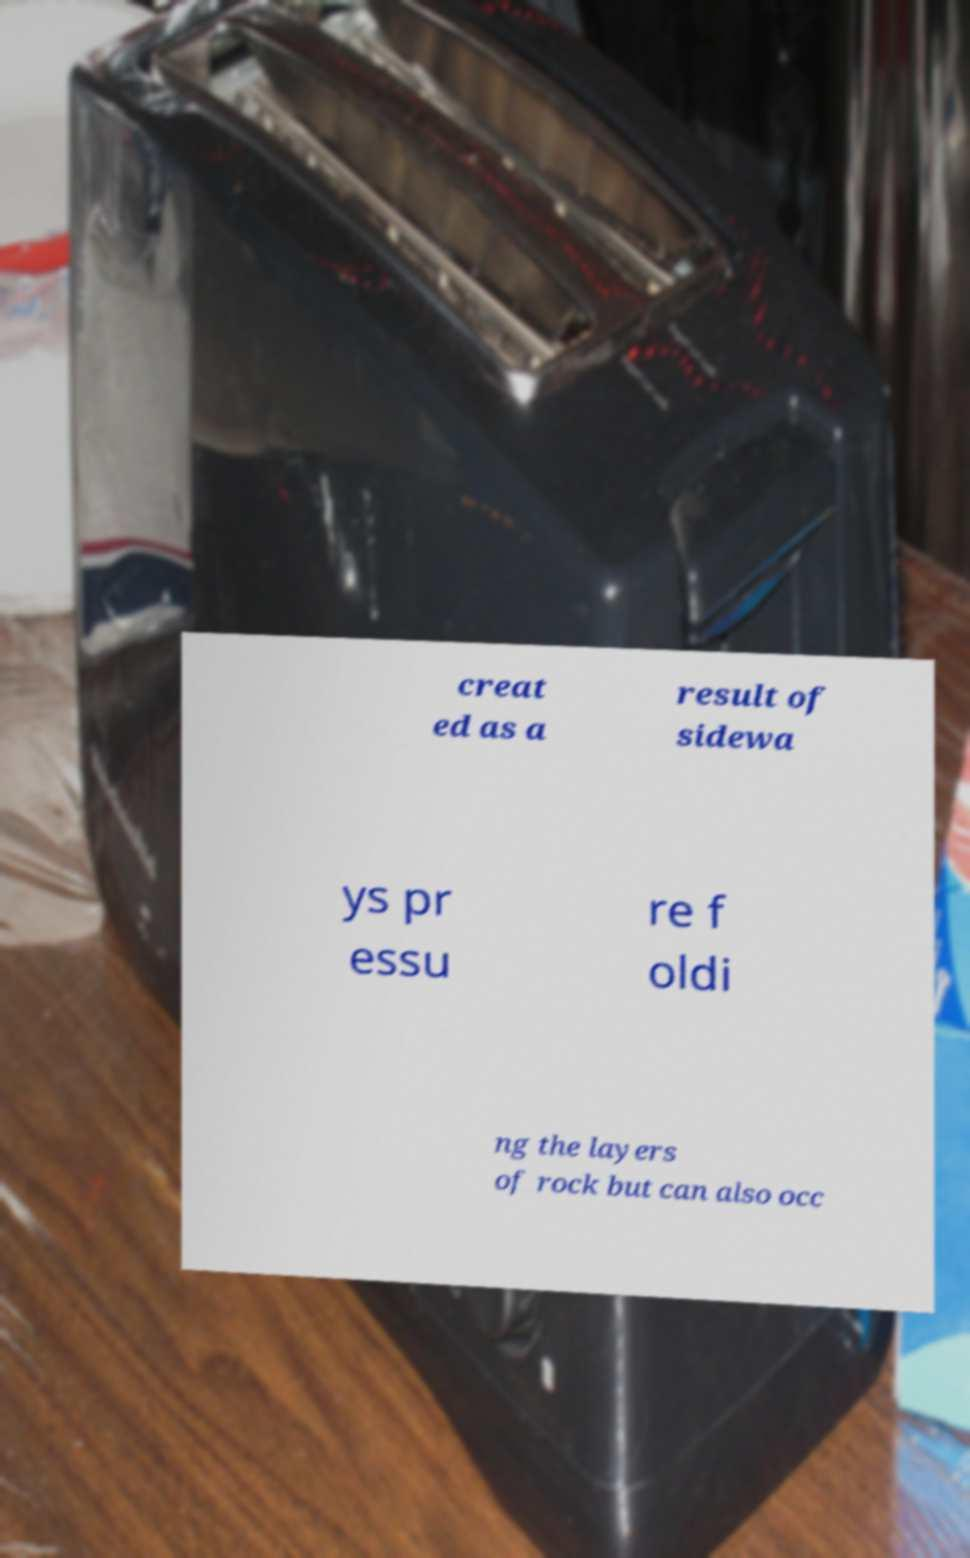For documentation purposes, I need the text within this image transcribed. Could you provide that? creat ed as a result of sidewa ys pr essu re f oldi ng the layers of rock but can also occ 